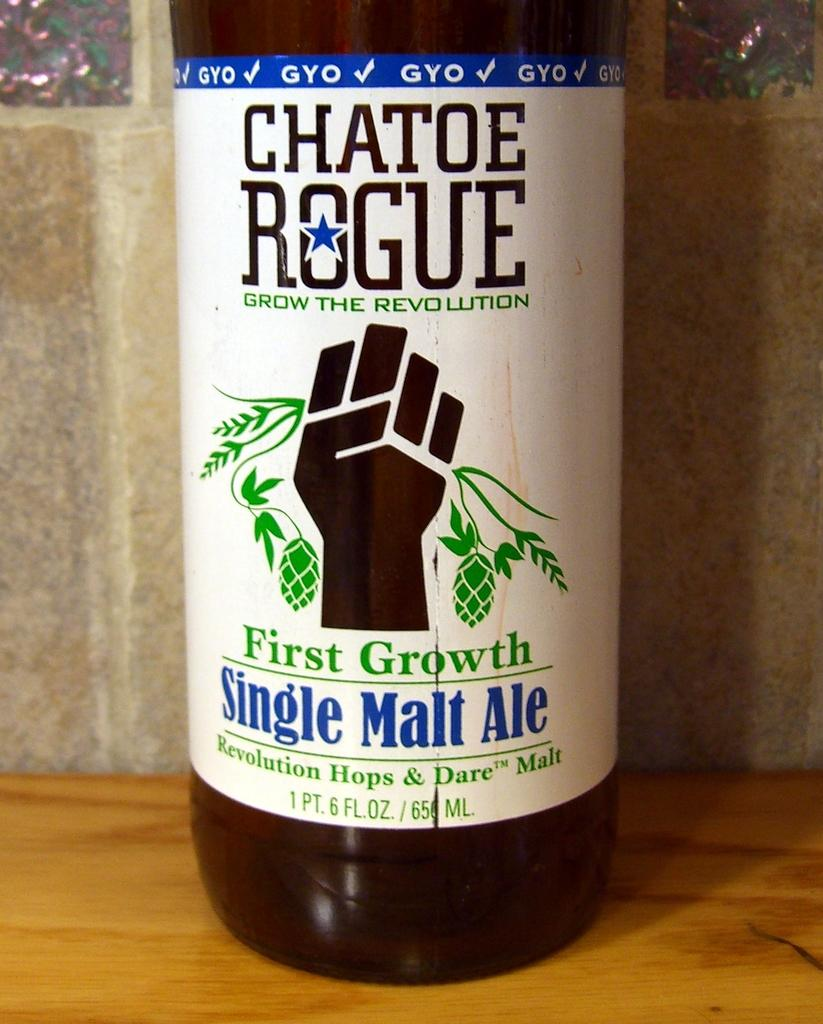<image>
Share a concise interpretation of the image provided. A closeup of the label for Chatoe Rogue First Growth Single Malt Ale. 